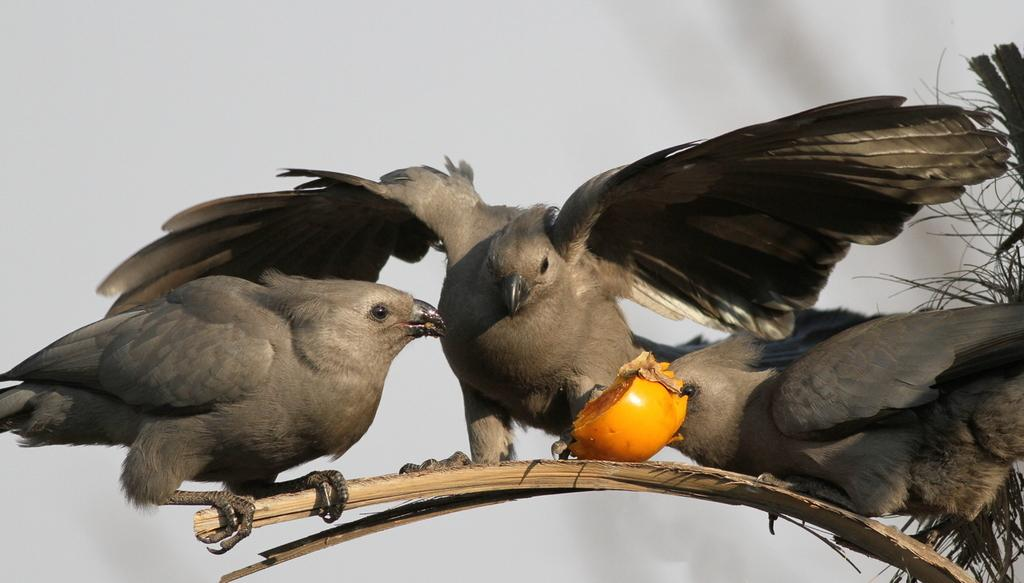What type of animals can be seen in the image? There are birds in the image. Where are the birds located? The birds are on a tree branch. What else is present in the image besides the birds? There is a fruit in the image. What type of scarf is the bird wearing in the image? There is no scarf present in the image; the birds are not wearing any clothing. 